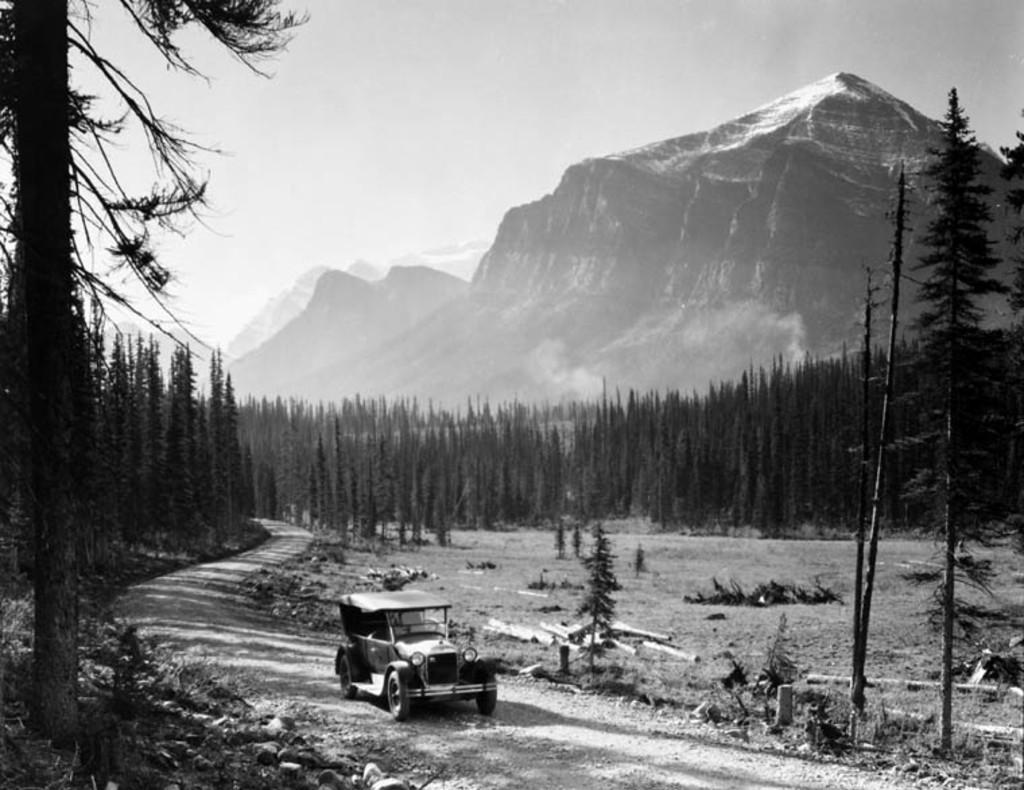Please provide a concise description of this image. In the image we can see mountains, trees, path and the sky. We can even see the vehicle. 